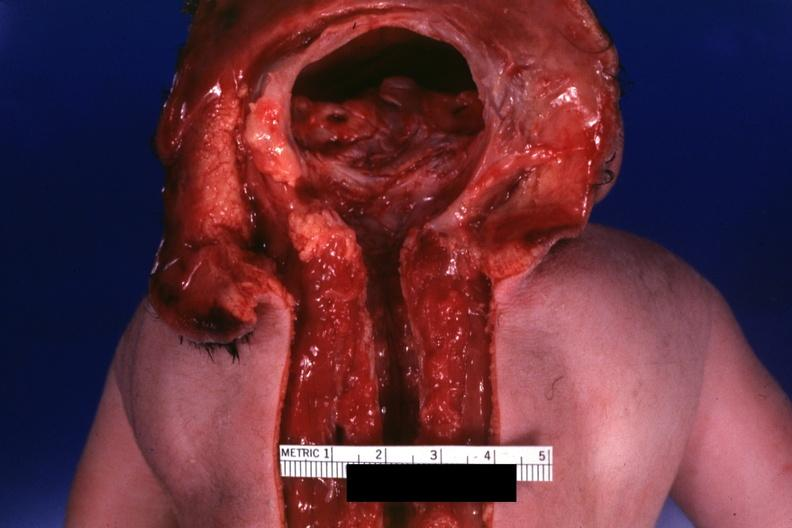what is no chromosomal defects lived?
Answer the question using a single word or phrase. One day 